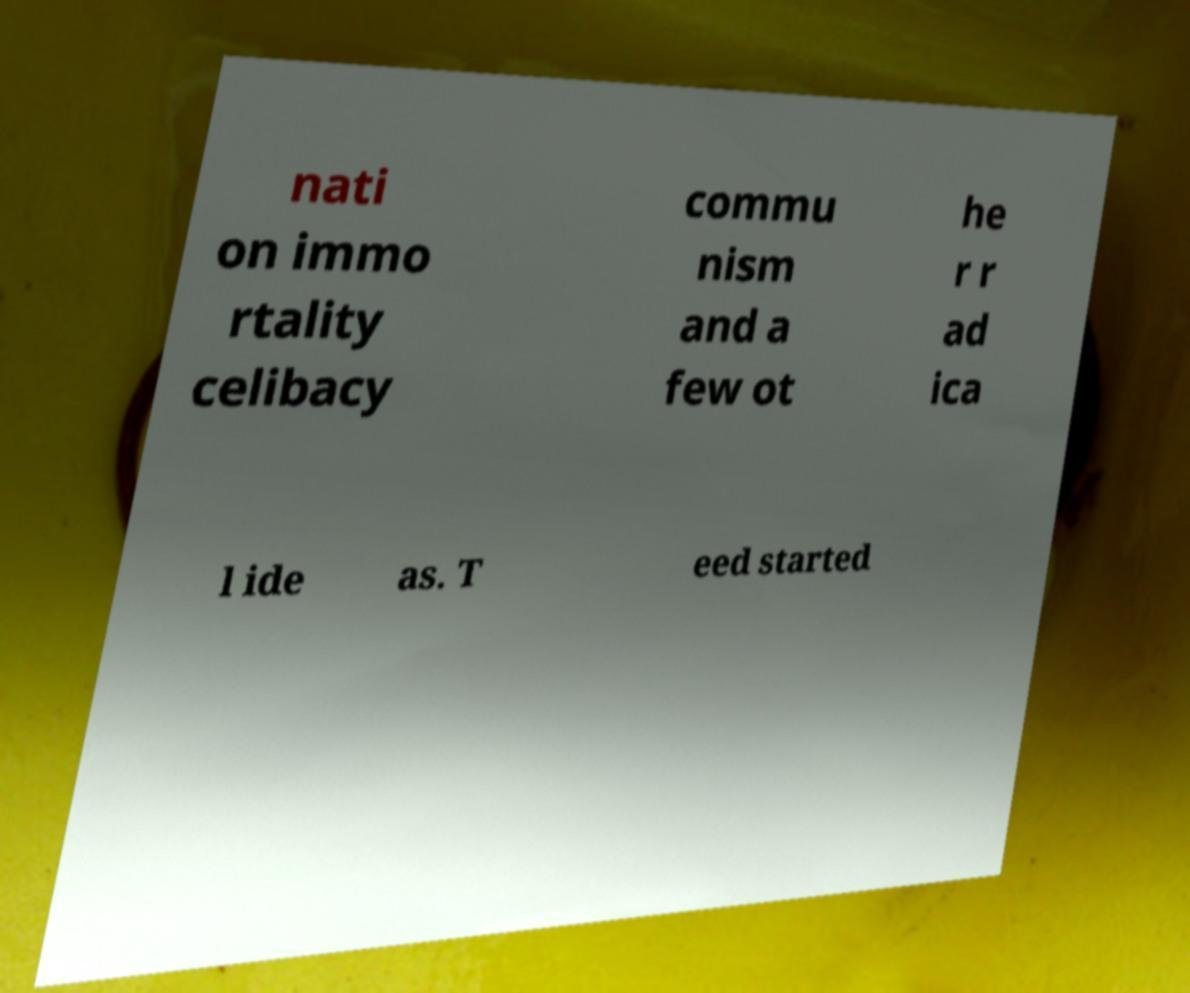I need the written content from this picture converted into text. Can you do that? nati on immo rtality celibacy commu nism and a few ot he r r ad ica l ide as. T eed started 